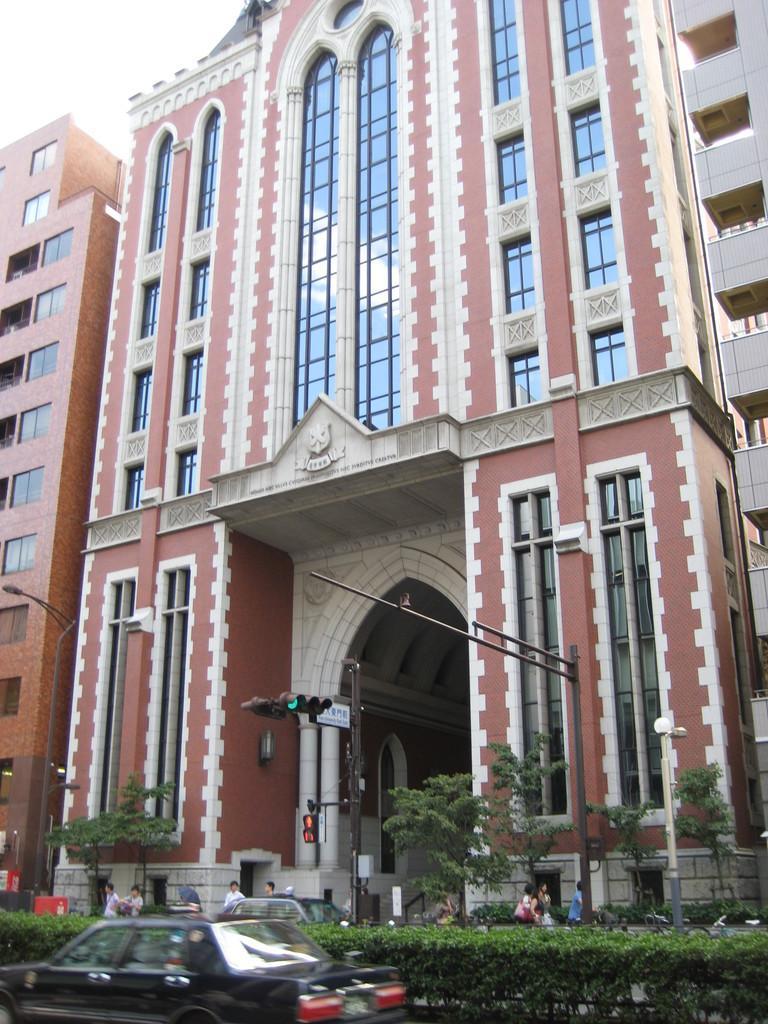Could you give a brief overview of what you see in this image? In this picture there is a building in the center of the image and there is a traffic pole in the center of the image, there are cars and plants at the bottom side of the image, there are people at the bottom side of the image. 